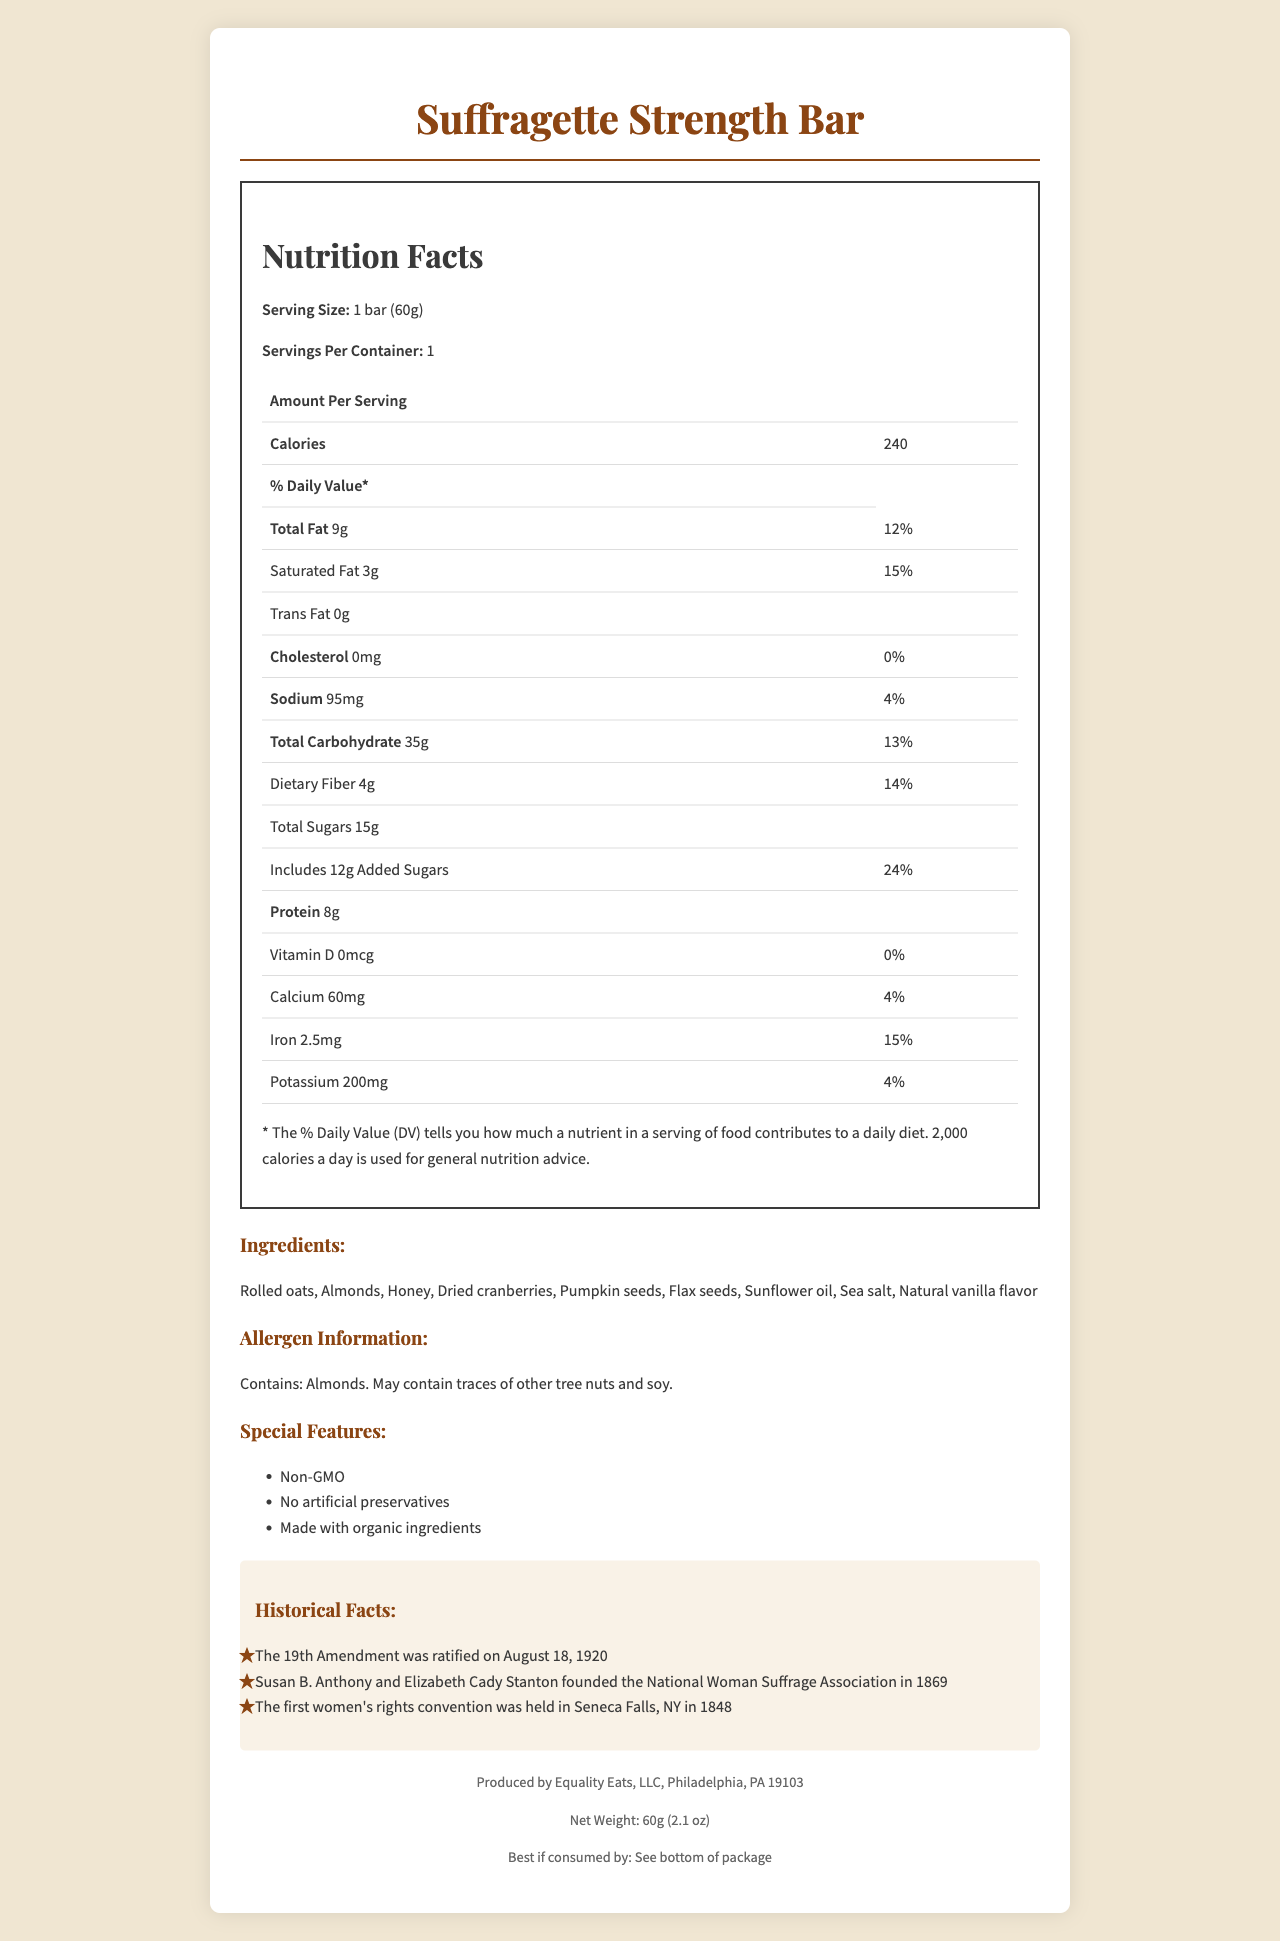what is the serving size of the Suffragette Strength Bar? The serving size is listed as 1 bar (60g) in the Nutrition Facts section.
Answer: 1 bar (60g) what percentage of daily iron does one serving of the energy bar provide? The Nutrition Facts section indicates that one serving provides 15% of the daily value for iron.
Answer: 15% what are the main ingredients of the Suffragette Strength Bar? The ingredients are listed under the Ingredients section.
Answer: Rolled oats, Almonds, Honey, Dried cranberries, Pumpkin seeds, Flax seeds, Sunflower oil, Sea salt, Natural vanilla flavor how many grams of protein are in one serving? The Nutrition Facts section lists 8g of protein per serving.
Answer: 8g how much cholesterol is in one bar? The Nutrition Facts section states that the bar contains 0mg of cholesterol.
Answer: 0mg what is the total carbohydrate daily value percentage? The Nutrition Facts section indicates that the total carbohydrate daily value percentage is 13%.
Answer: 13% what is the expiration date of the product? The expiration date is mentioned in the footer as "Best if consumed by: See bottom of package."
Answer: See bottom of package which of the following contains the highest amount of fat in the bar? A. Total Fat B. Saturated Fat C. Trans Fat The Nutrition Facts section lists Total Fat as 9g, Saturated Fat as 3g, and Trans Fat as 0g. Thus, Total Fat has the highest amount.
Answer: A how many special features are highlighted in the document? A. 1 B. 2 C. 3 D. 4 There are three special features listed: Non-GMO, No artificial preservatives, and Made with organic ingredients.
Answer: C is the Suffragette Strength Bar suitable for someone allergic to almonds? The Allergen Information section warns that the product contains almonds.
Answer: No summarize the main features of the Suffragette Strength Bar. The document offers a detailed breakdown of the energy bar's nutritional content, ingredients, allergen info, and special features while honoring the 19th Amendment centennial.
Answer: The Suffragette Strength Bar is a commemorative energy bar with a serving size of 1 bar (60g). It provides 240 calories per serving and includes ingredients such as rolled oats, almonds, and honey. The product contains 9g of total fat and 8g of protein. It highlights special features like being non-GMO and containing organic ingredients. The bar commemorates the 19th Amendment with historical facts and is produced by Equality Eats, LLC. what is the primary sweetening agent in the energy bar? Honey is listed as one of the main ingredients, serving as the primary sweetening agent.
Answer: Honey how many historical facts are associated with the Suffragette Strength Bar? There are three historical facts listed in the Historical Facts section.
Answer: 3 who founded the National Woman Suffrage Association? According to the historical facts, Susan B. Anthony and Elizabeth Cady Stanton founded the National Woman Suffrage Association.
Answer: Susan B. Anthony and Elizabeth Cady Stanton does the Suffragette Strength Bar contain any artificial preservatives? The Special Features section states that the bar contains no artificial preservatives.
Answer: No what is the recommended daily calorie intake used for general nutrition advice? The Nutrition Facts section mentions that 2,000 calories a day is used for general nutrition advice.
Answer: 2,000 calories what is the primary purpose of the commemorate energy bar? The primary purpose of the energy bar cannot be determined from the visual information provided in the document.
Answer: I don't know 